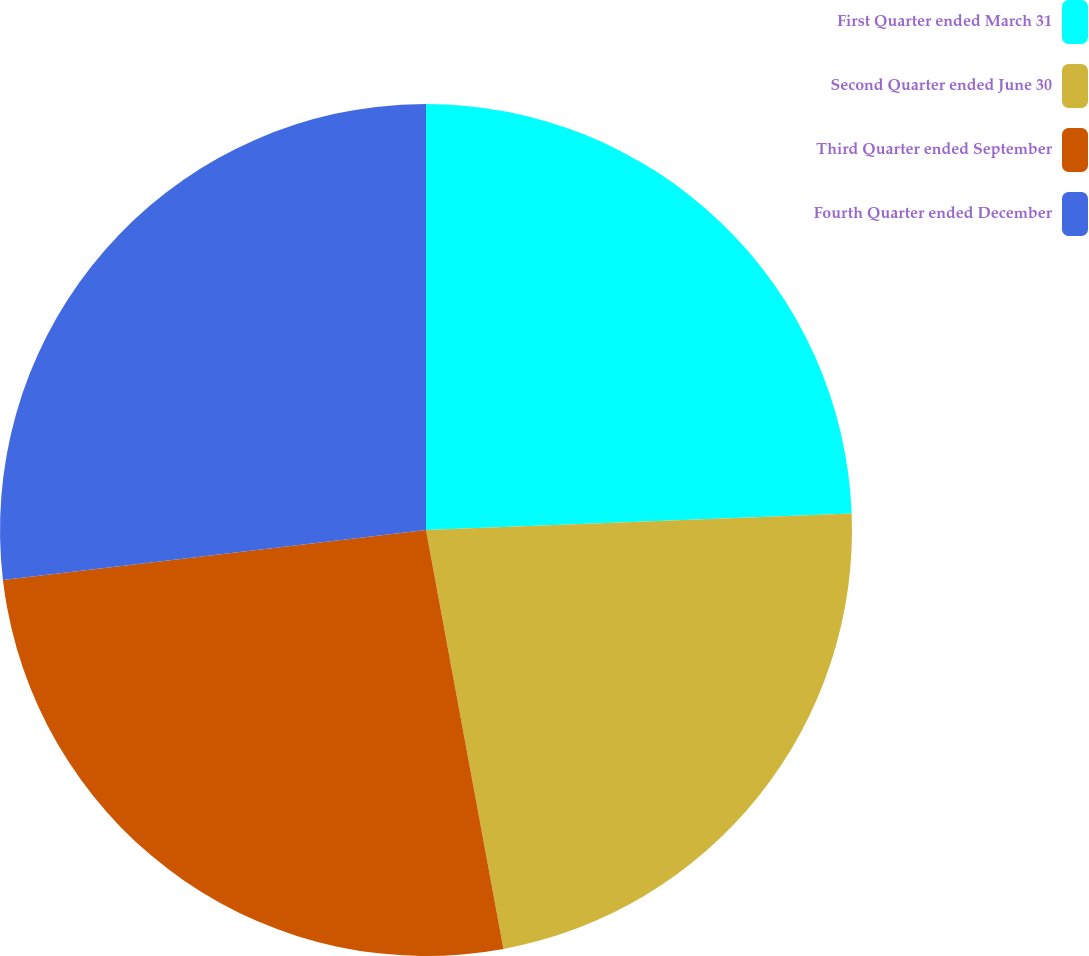<chart> <loc_0><loc_0><loc_500><loc_500><pie_chart><fcel>First Quarter ended March 31<fcel>Second Quarter ended June 30<fcel>Third Quarter ended September<fcel>Fourth Quarter ended December<nl><fcel>24.38%<fcel>22.71%<fcel>26.04%<fcel>26.87%<nl></chart> 